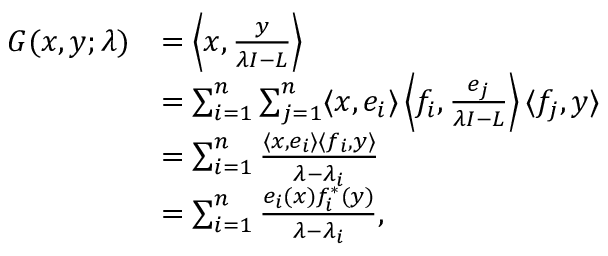<formula> <loc_0><loc_0><loc_500><loc_500>{ \begin{array} { r l } { G ( x , y ; \lambda ) } & { = \left \langle x , { \frac { y } { \lambda I - L } } \right \rangle } \\ & { = \sum _ { i = 1 } ^ { n } \sum _ { j = 1 } ^ { n } \langle x , e _ { i } \rangle \left \langle f _ { i } , { \frac { e _ { j } } { \lambda I - L } } \right \rangle \langle f _ { j } , y \rangle } \\ & { = \sum _ { i = 1 } ^ { n } { \frac { \langle x , e _ { i } \rangle \langle f _ { i } , y \rangle } { \lambda - \lambda _ { i } } } } \\ & { = \sum _ { i = 1 } ^ { n } { \frac { e _ { i } ( x ) f _ { i } ^ { * } ( y ) } { \lambda - \lambda _ { i } } } , } \end{array} }</formula> 